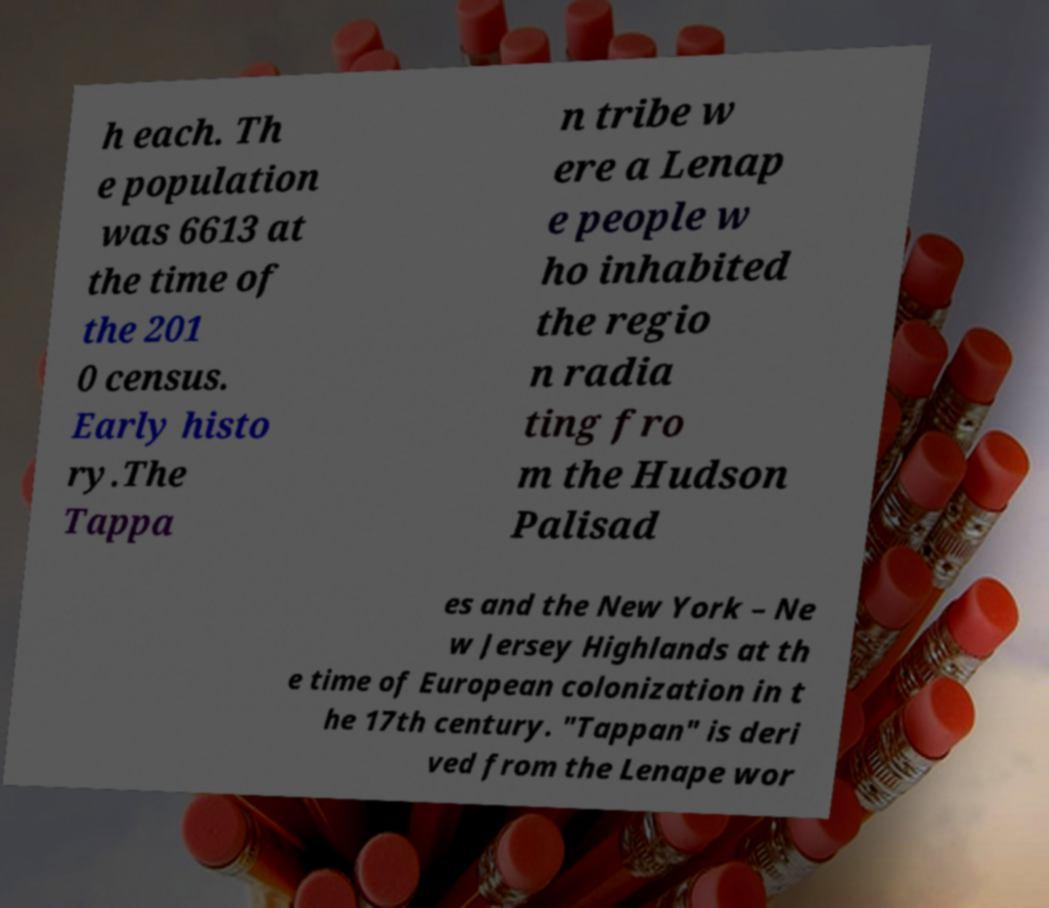Please read and relay the text visible in this image. What does it say? h each. Th e population was 6613 at the time of the 201 0 census. Early histo ry.The Tappa n tribe w ere a Lenap e people w ho inhabited the regio n radia ting fro m the Hudson Palisad es and the New York – Ne w Jersey Highlands at th e time of European colonization in t he 17th century. "Tappan" is deri ved from the Lenape wor 